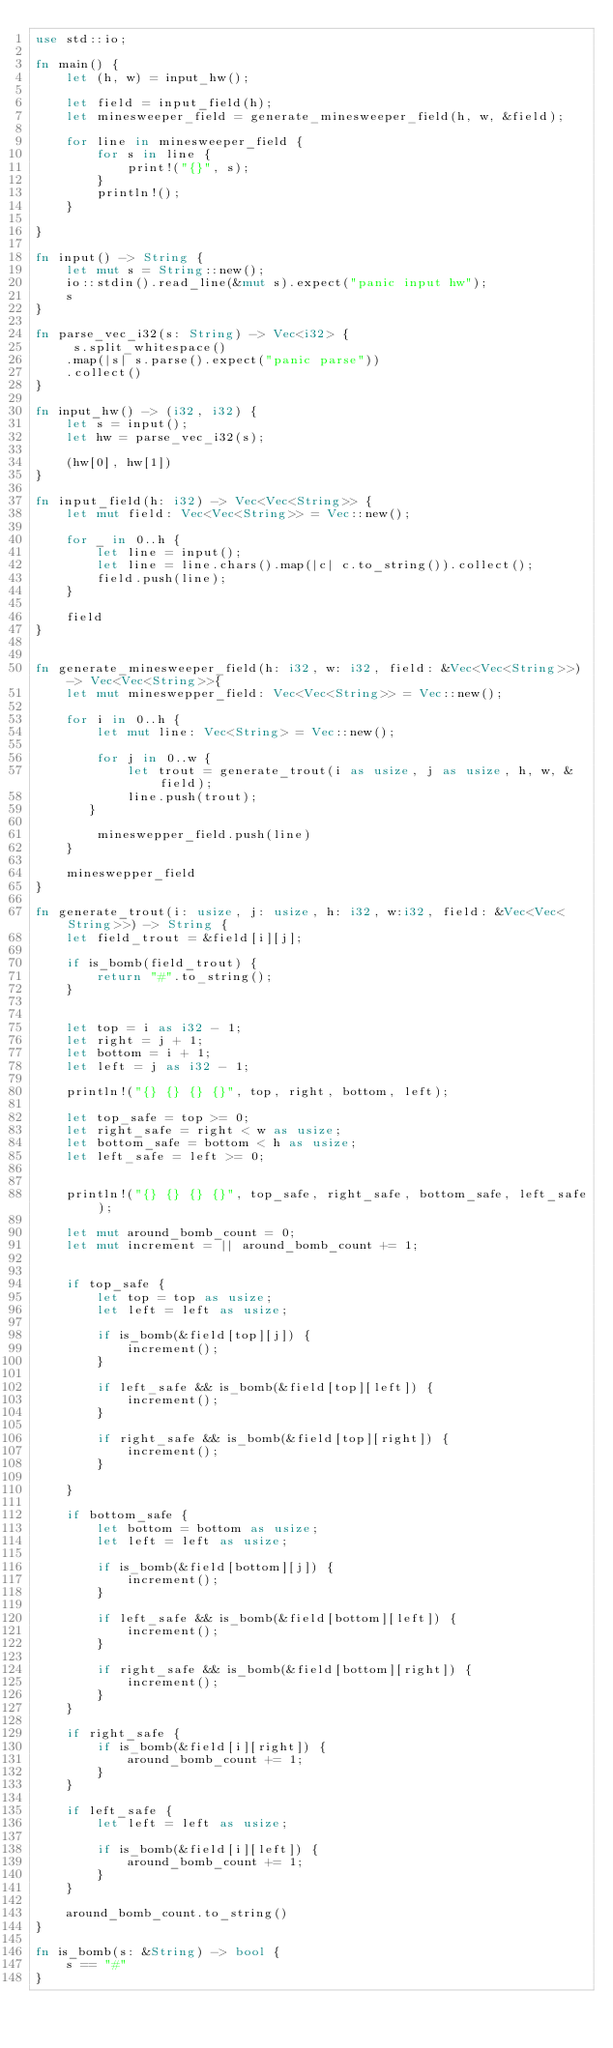<code> <loc_0><loc_0><loc_500><loc_500><_Rust_>use std::io;

fn main() {
    let (h, w) = input_hw();

    let field = input_field(h);
    let minesweeper_field = generate_minesweeper_field(h, w, &field);

    for line in minesweeper_field {
        for s in line {
            print!("{}", s);
        }
        println!();
    }

}

fn input() -> String {
    let mut s = String::new();
    io::stdin().read_line(&mut s).expect("panic input hw");
    s
}

fn parse_vec_i32(s: String) -> Vec<i32> {
     s.split_whitespace()
    .map(|s| s.parse().expect("panic parse"))
    .collect()
}

fn input_hw() -> (i32, i32) {
    let s = input();
    let hw = parse_vec_i32(s);

    (hw[0], hw[1])
}

fn input_field(h: i32) -> Vec<Vec<String>> {
    let mut field: Vec<Vec<String>> = Vec::new();

    for _ in 0..h {
        let line = input();
        let line = line.chars().map(|c| c.to_string()).collect();
        field.push(line);
    }

    field
}


fn generate_minesweeper_field(h: i32, w: i32, field: &Vec<Vec<String>>) -> Vec<Vec<String>>{
    let mut mineswepper_field: Vec<Vec<String>> = Vec::new();

    for i in 0..h {
        let mut line: Vec<String> = Vec::new();

        for j in 0..w {
            let trout = generate_trout(i as usize, j as usize, h, w, &field);
            line.push(trout);
       }

        mineswepper_field.push(line)
    }

    mineswepper_field
}

fn generate_trout(i: usize, j: usize, h: i32, w:i32, field: &Vec<Vec<String>>) -> String {
    let field_trout = &field[i][j];

    if is_bomb(field_trout) {
        return "#".to_string();
    }


    let top = i as i32 - 1;
    let right = j + 1;
    let bottom = i + 1;
    let left = j as i32 - 1;

    println!("{} {} {} {}", top, right, bottom, left);

    let top_safe = top >= 0;
    let right_safe = right < w as usize;
    let bottom_safe = bottom < h as usize;
    let left_safe = left >= 0;


    println!("{} {} {} {}", top_safe, right_safe, bottom_safe, left_safe);

    let mut around_bomb_count = 0;
    let mut increment = || around_bomb_count += 1;


    if top_safe {
        let top = top as usize;
        let left = left as usize;

        if is_bomb(&field[top][j]) {
            increment();
        }

        if left_safe && is_bomb(&field[top][left]) {
            increment();
        }

        if right_safe && is_bomb(&field[top][right]) {
            increment();
        }

    }

    if bottom_safe {
        let bottom = bottom as usize;
        let left = left as usize;

        if is_bomb(&field[bottom][j]) {
            increment();
        }

        if left_safe && is_bomb(&field[bottom][left]) {
            increment();
        }

        if right_safe && is_bomb(&field[bottom][right]) {
            increment();
        }
    }

    if right_safe {
        if is_bomb(&field[i][right]) {
            around_bomb_count += 1;
        }
    }

    if left_safe {
        let left = left as usize;

        if is_bomb(&field[i][left]) {
            around_bomb_count += 1;
        }
    }

    around_bomb_count.to_string()
}

fn is_bomb(s: &String) -> bool {
    s == "#"
}</code> 